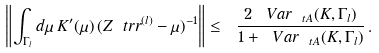Convert formula to latex. <formula><loc_0><loc_0><loc_500><loc_500>\left \| \int _ { \Gamma _ { l } } d \mu \, K ^ { \prime } ( \mu ) \, ( Z _ { \ } t r r ^ { ( l ) } - \mu ) ^ { - 1 } \right \| \leq \ \frac { 2 \, \ V a r _ { \ t A } ( K , \Gamma _ { l } ) } { 1 + \ V a r _ { \ t A } ( K , \Gamma _ { l } ) } \, .</formula> 